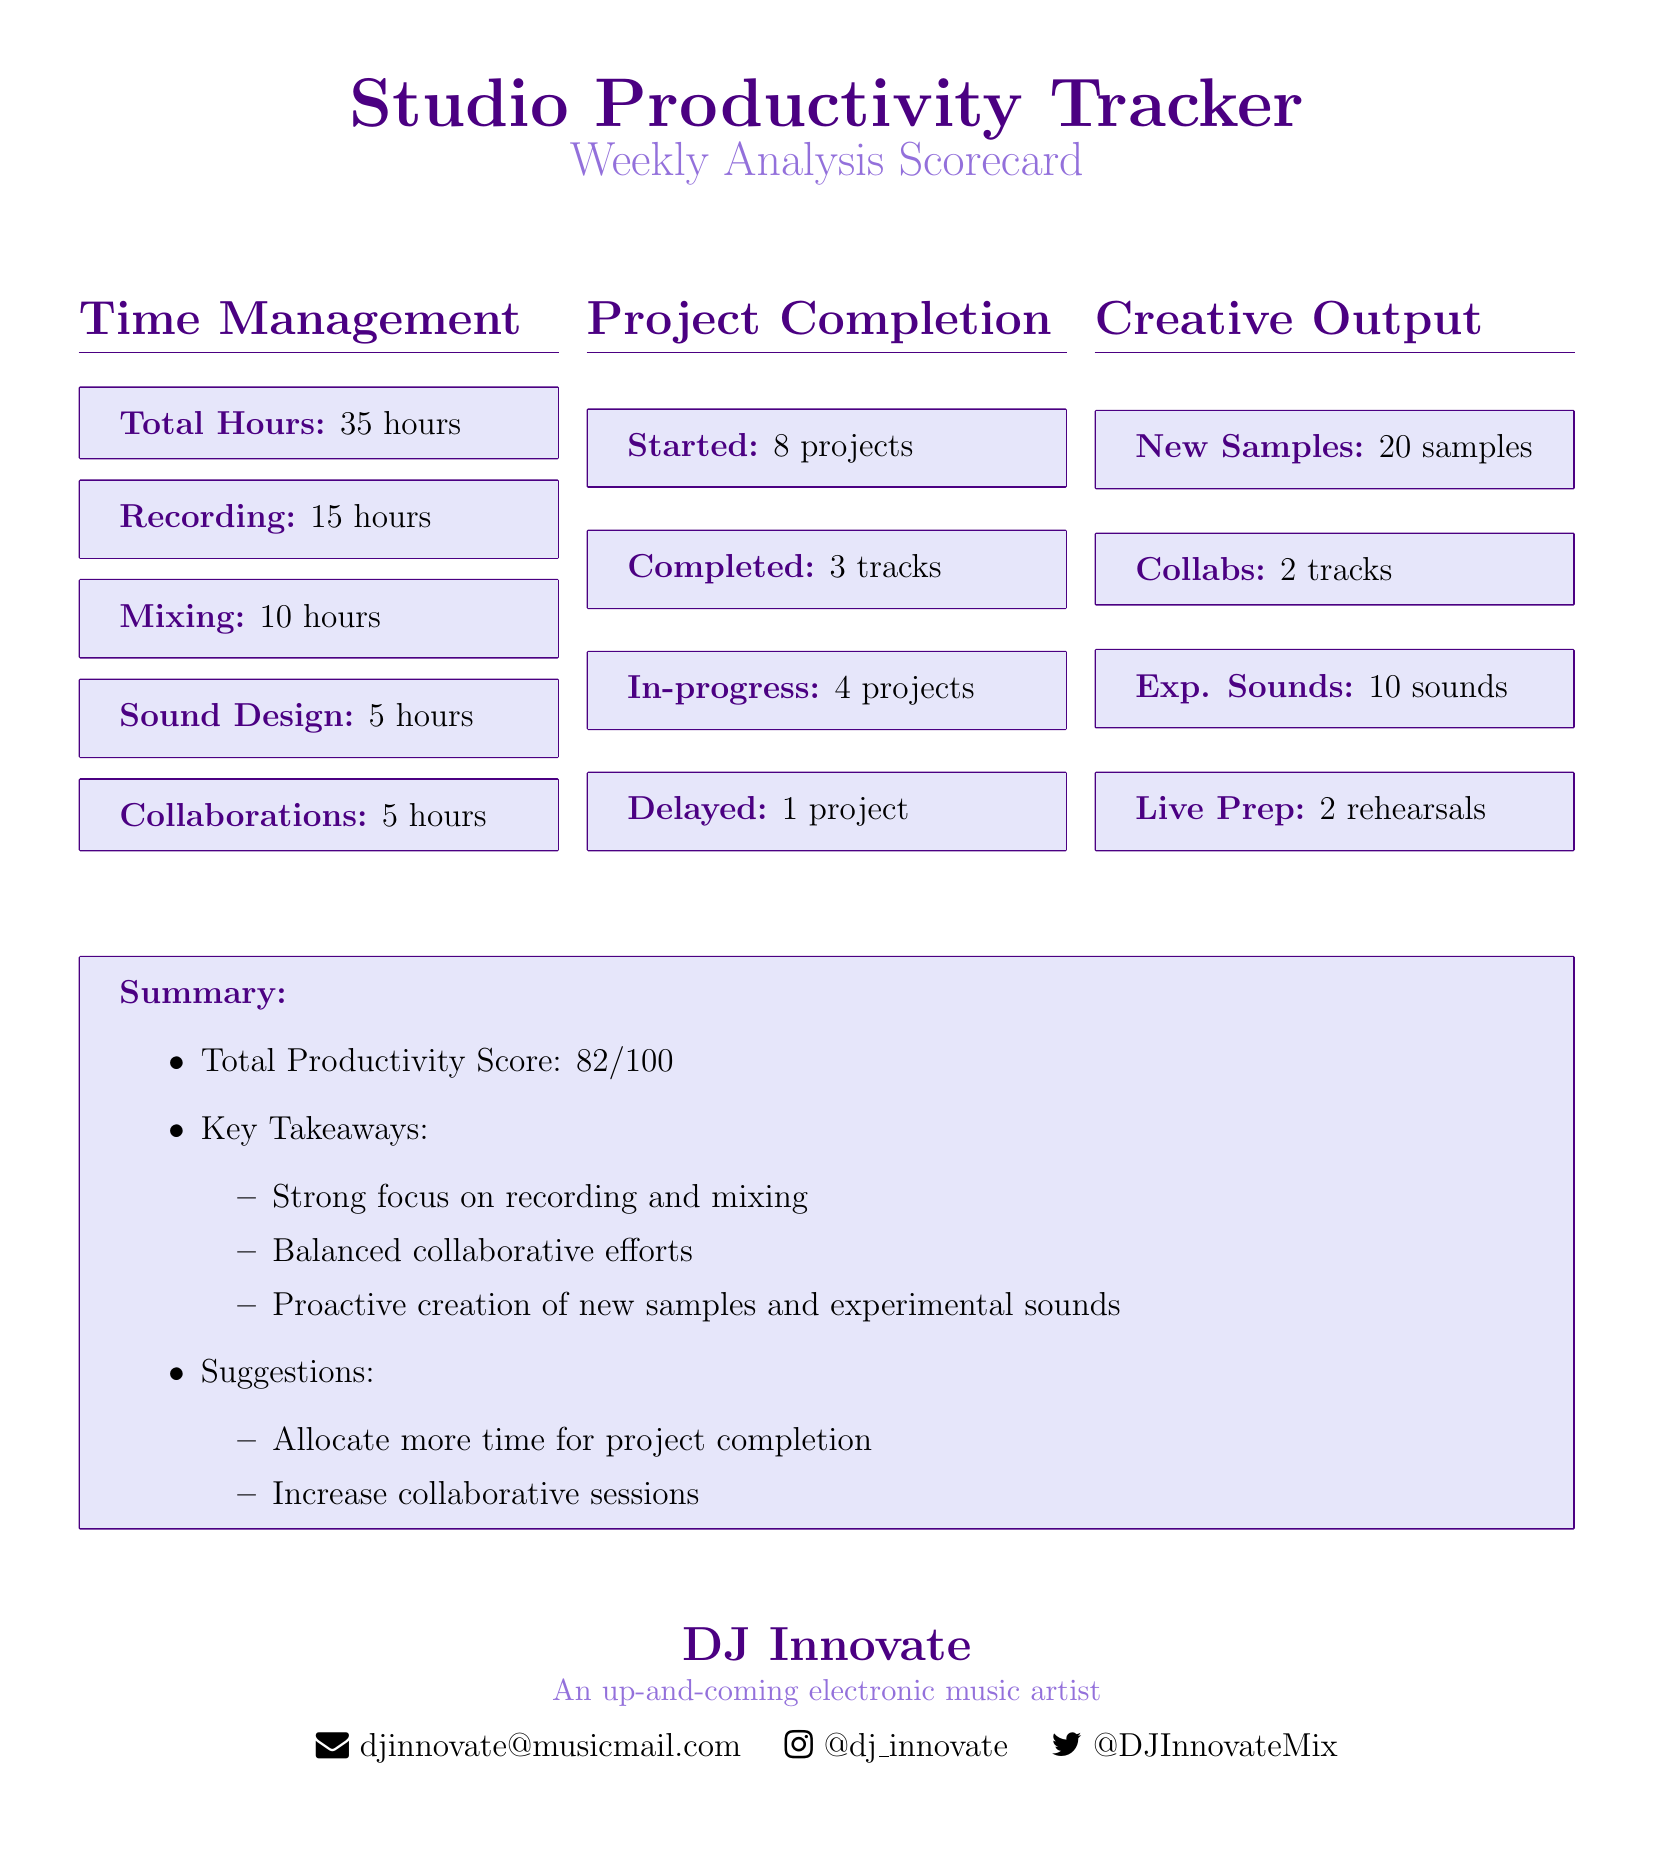what is the total hours worked? The total hours worked is summarized in the "Time Management" section of the document.
Answer: 35 hours how many projects were completed? The number of completed projects is listed in the "Project Completion" section.
Answer: 3 tracks what was the focus of the recording time? The recording time is provided under "Time Management," which reveals where the effort was concentrated.
Answer: 15 hours how many new samples were created? The "Creative Output" section includes the number of new samples created during the week.
Answer: 20 samples what is the total productivity score? The total productivity score at the end of the document summarizes overall performance.
Answer: 82/100 how many projects are in-progress? The document specifies the number of projects currently in-progress under "Project Completion."
Answer: 4 projects what is one suggestion for improvement? Suggestions for improving productivity are provided in the summary section, highlighting areas to focus on.
Answer: Increase collaborative sessions how many hours were spent on sound design? The "Time Management" section lists the hours dedicated to sound design specifically.
Answer: 5 hours how many collaborations were initiated? The collaborations initiated during the week are detailed in the "Creative Output" section.
Answer: 2 tracks 